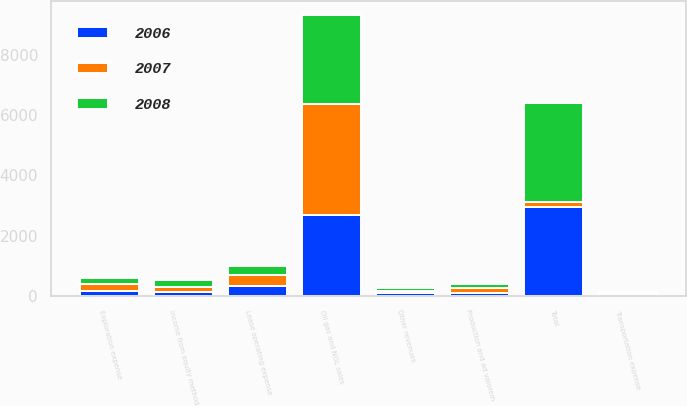Convert chart. <chart><loc_0><loc_0><loc_500><loc_500><stacked_bar_chart><ecel><fcel>Oil gas and NGL sales<fcel>Income from equity method<fcel>Other revenues<fcel>Total<fcel>Lease operating expense<fcel>Production and ad valorem<fcel>Transportation expense<fcel>Exploration expense<nl><fcel>2007<fcel>3651<fcel>174<fcel>76<fcel>174<fcel>371<fcel>166<fcel>57<fcel>217<nl><fcel>2008<fcel>2966<fcel>211<fcel>95<fcel>3272<fcel>322<fcel>114<fcel>52<fcel>219<nl><fcel>2006<fcel>2701<fcel>139<fcel>100<fcel>2940<fcel>317<fcel>109<fcel>29<fcel>168<nl></chart> 